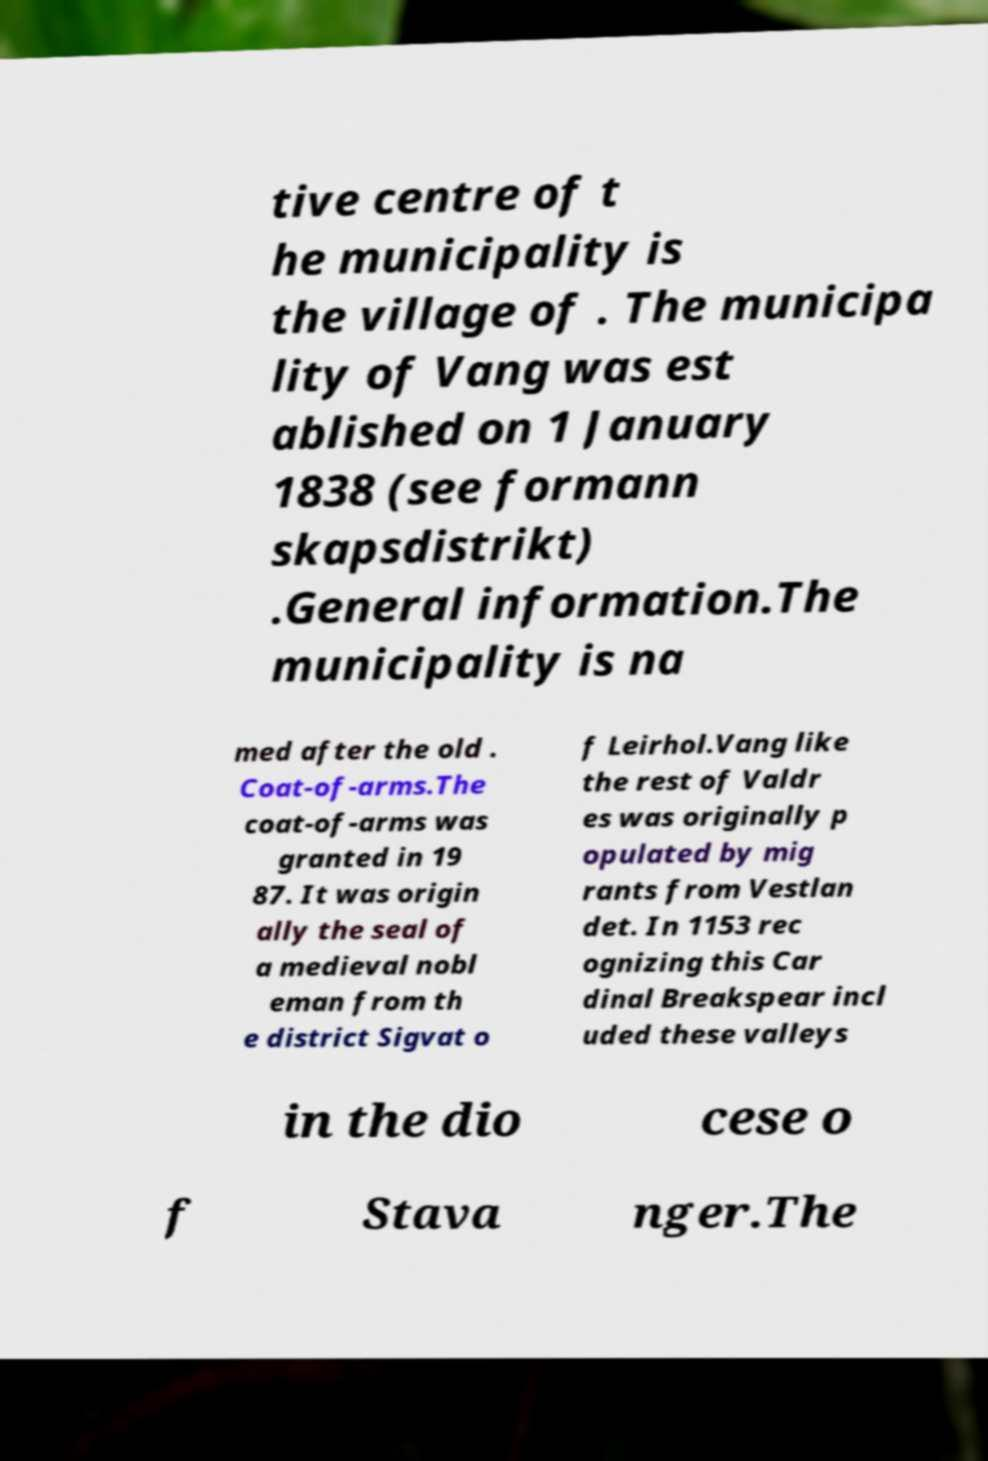Please read and relay the text visible in this image. What does it say? tive centre of t he municipality is the village of . The municipa lity of Vang was est ablished on 1 January 1838 (see formann skapsdistrikt) .General information.The municipality is na med after the old . Coat-of-arms.The coat-of-arms was granted in 19 87. It was origin ally the seal of a medieval nobl eman from th e district Sigvat o f Leirhol.Vang like the rest of Valdr es was originally p opulated by mig rants from Vestlan det. In 1153 rec ognizing this Car dinal Breakspear incl uded these valleys in the dio cese o f Stava nger.The 